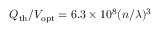Convert formula to latex. <formula><loc_0><loc_0><loc_500><loc_500>Q _ { t h } / V _ { o p t } = 6 . 3 \times 1 0 ^ { 8 } ( n / \lambda ) ^ { 3 }</formula> 